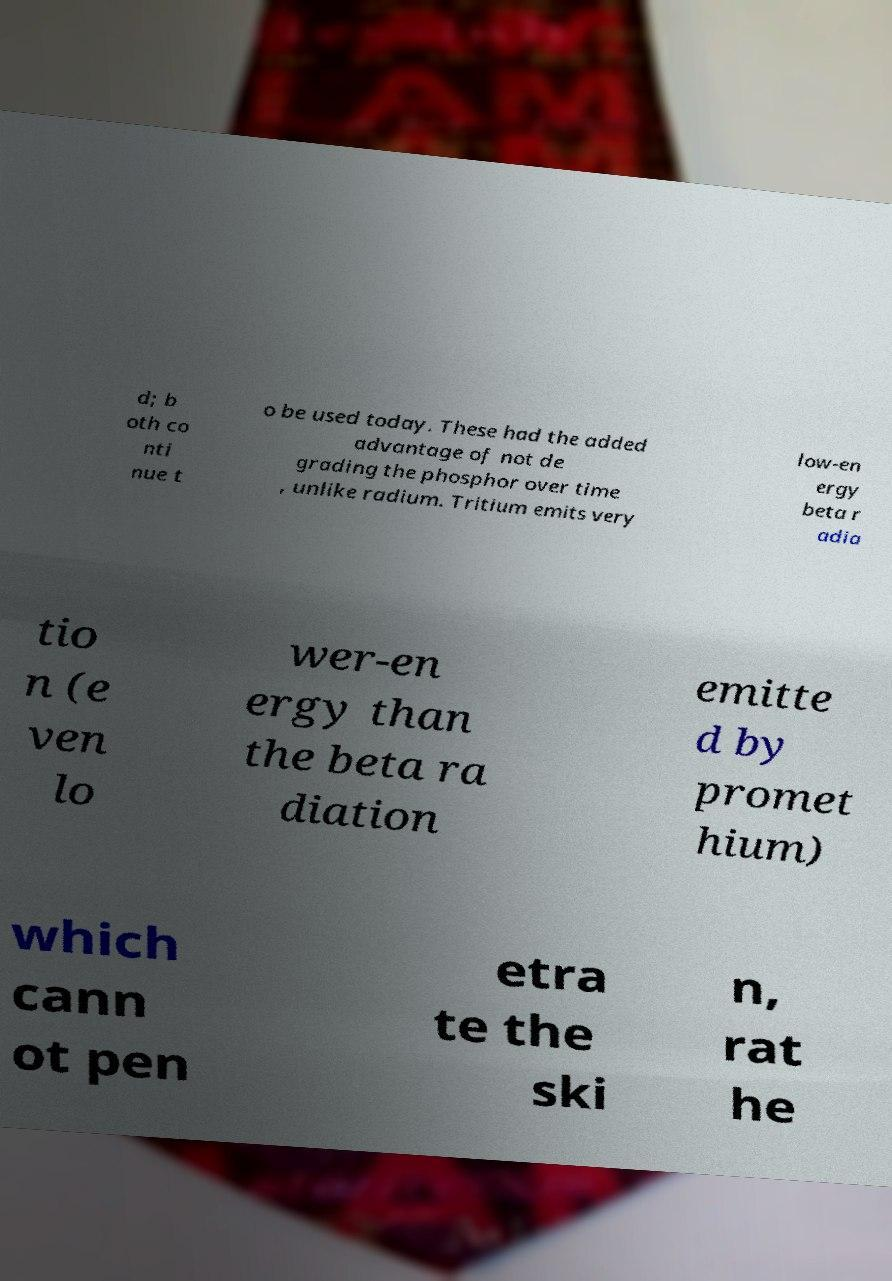There's text embedded in this image that I need extracted. Can you transcribe it verbatim? d; b oth co nti nue t o be used today. These had the added advantage of not de grading the phosphor over time , unlike radium. Tritium emits very low-en ergy beta r adia tio n (e ven lo wer-en ergy than the beta ra diation emitte d by promet hium) which cann ot pen etra te the ski n, rat he 